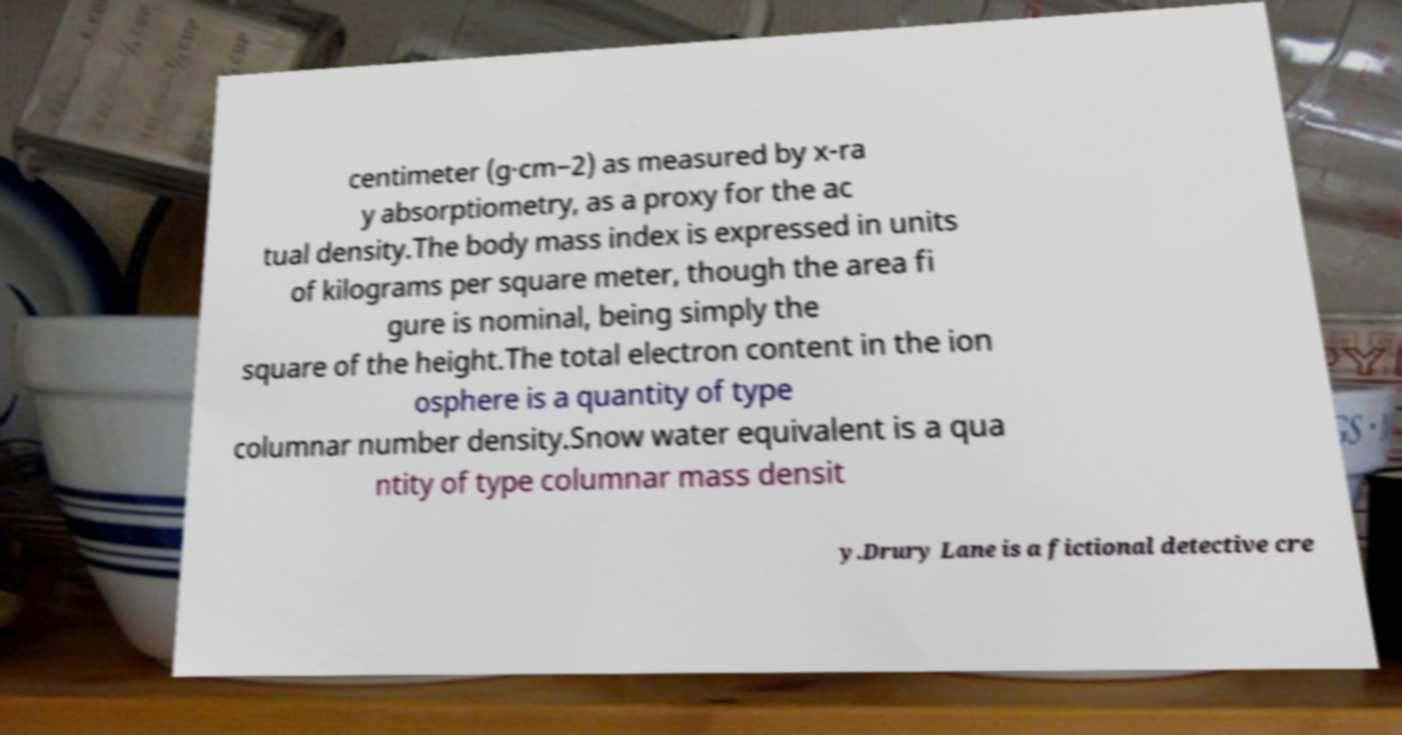I need the written content from this picture converted into text. Can you do that? centimeter (g·cm−2) as measured by x-ra y absorptiometry, as a proxy for the ac tual density.The body mass index is expressed in units of kilograms per square meter, though the area fi gure is nominal, being simply the square of the height.The total electron content in the ion osphere is a quantity of type columnar number density.Snow water equivalent is a qua ntity of type columnar mass densit y.Drury Lane is a fictional detective cre 